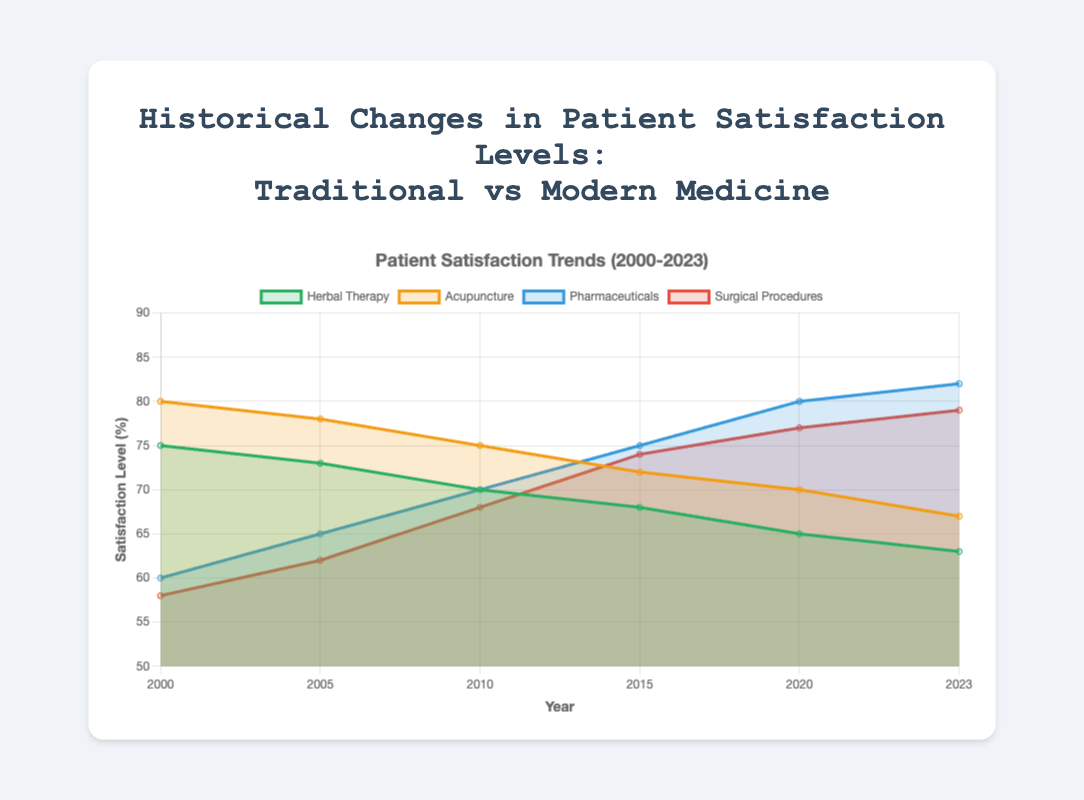what does the chart title indicate? The chart title is "Historical Changes in Patient Satisfaction Levels: Traditional vs Modern Medicine", which indicates that the chart shows trends in patient satisfaction levels for traditional and modern medicine from 2000 to 2023.
Answer: Trends in patient satisfaction levels how many therapies/treatments are depicted in the chart? The chart shows four lines which represent the satisfaction levels of four different therapies/treatments: Herbal Therapy, Acupuncture, Pharmaceuticals, and Surgical Procedures.
Answer: Four which treatment shows the highest satisfaction level in the year 2000? By looking at the chart, Acupuncture has the highest patient satisfaction level in 2000 with a satisfaction level of 80%.
Answer: Acupuncture how does satisfaction with herbal therapy change from 2000 to 2023? The satisfaction level with Herbal Therapy decreases from 75% in 2000 to 63% in 2023. The decrease can be calculated as 75 - 63 = 12%.
Answer: Decreases by 12% which treatment has seen an increase in satisfaction levels over the years? Both Pharmaceuticals and Surgical Procedures have seen an increase in satisfaction levels from 2000 to 2023.
Answer: Pharmaceuticals and Surgical Procedures in which year did pharmaceutical satisfaction surpass herbal therapy satisfaction? By examining the data points and lines on the chart, pharmaceutical satisfaction surpassed herbal therapy satisfaction in the year 2010.
Answer: 2010 what is the trend in satisfaction levels for acupuncture from 2000 to 2023? Satisfaction levels for Acupuncture have shown a downward trend, decreasing from 80% in 2000 to 67% in 2023. This indicates a drop of 13%.
Answer: Downward trend by 13% compare the satisfaction levels of surgical procedures and pharmaceuticals in 2023. In 2023, Pharmaceuticals have a satisfaction level of 82%, while Surgical Procedures have a satisfaction level of 79%. Pharmaceuticals have a higher satisfaction level by 3%.
Answer: Pharmaceuticals have 3% higher satisfaction what can you infer about patient satisfaction with traditional vs modern medicine over the years? Traditional medicine (Herbal Therapy and Acupuncture) shows a decreasing trend in patient satisfaction, while modern medicine (Pharmaceuticals and Surgical Procedures) displays an increasing trend. This indicates that over the years, patients have been more satisfied with modern treatments compared to traditional options.
Answer: Traditional decreasing, Modern increasing which has the highest satisfaction level in 2023, and what is it? Pharmaceuticals have the highest satisfaction level in 2023, with a value of 82%.
Answer: Pharmaceuticals at 82% 